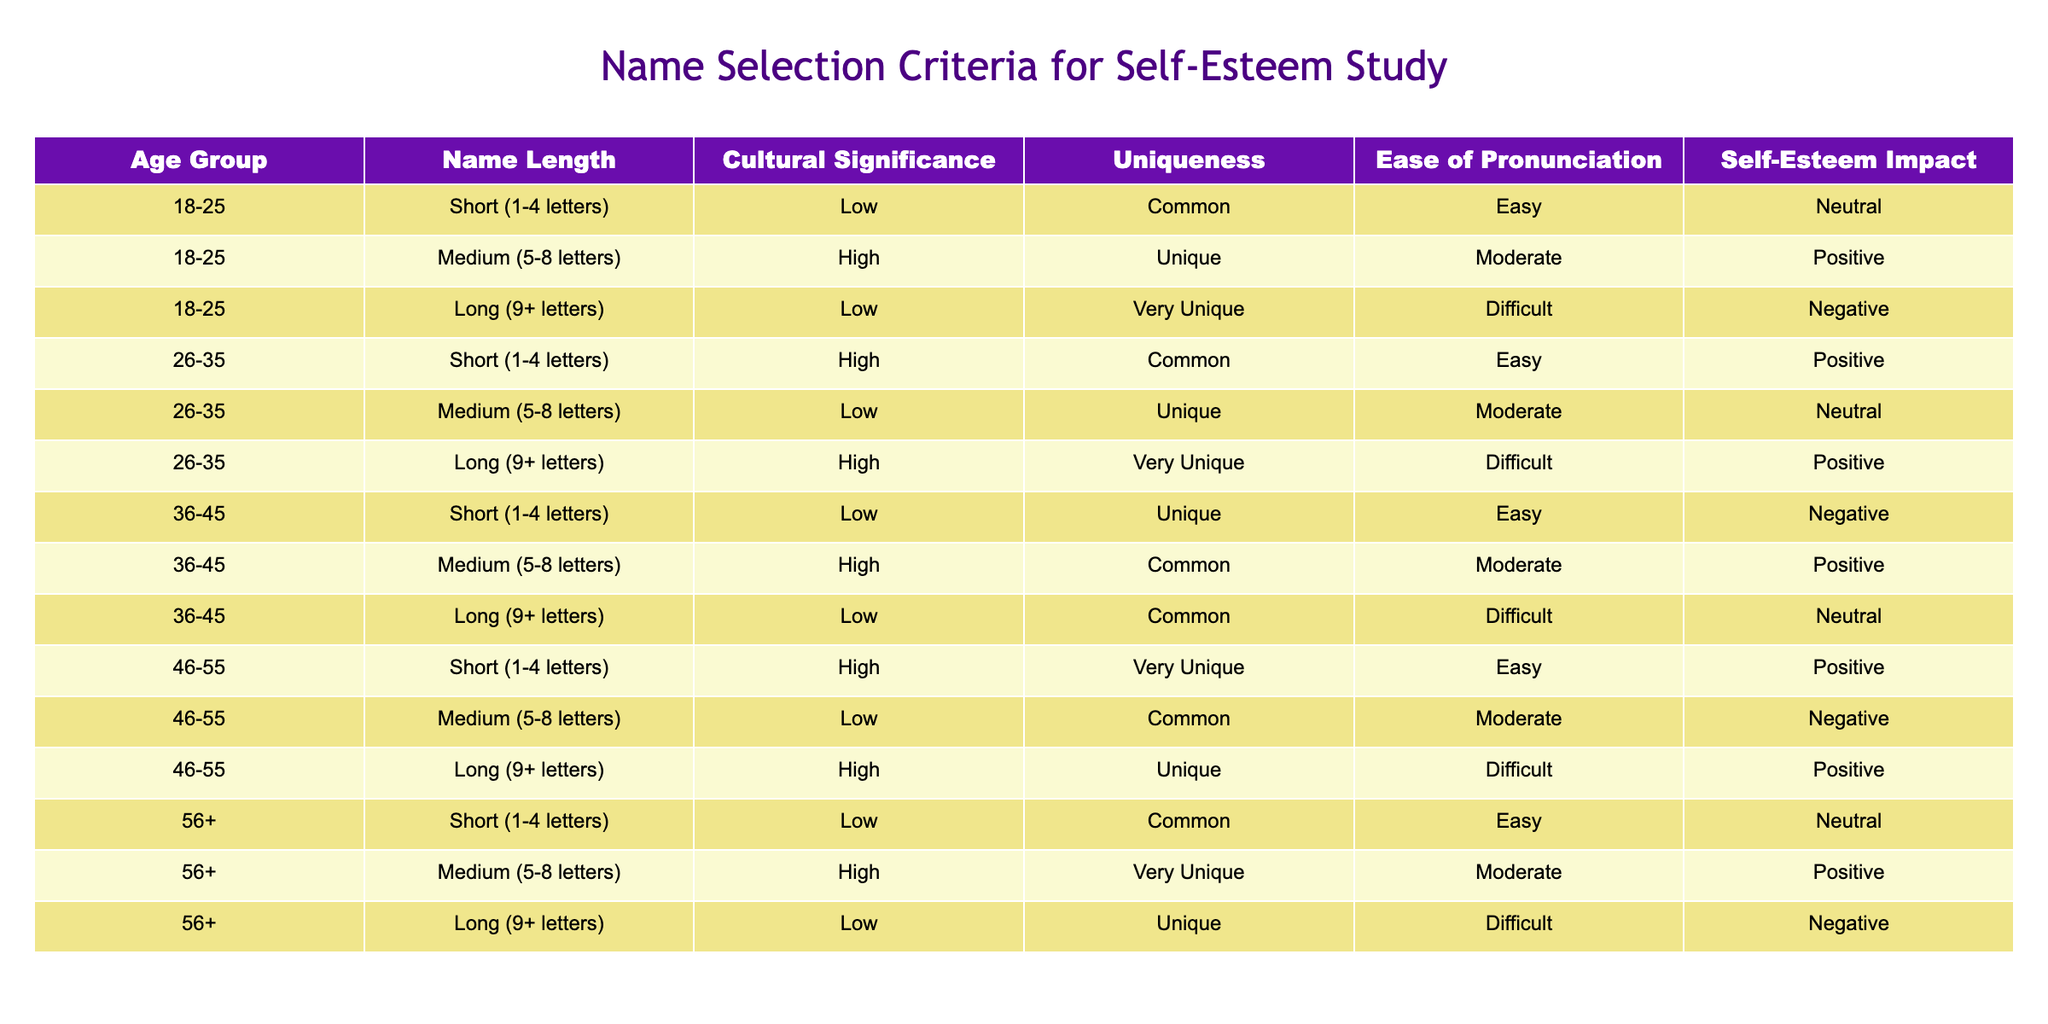What is the self-esteem impact for names of medium length in the 36-45 age group? The self-esteem impact column shows that for the 36-45 age group, the medium length names have a positive impact. I find this in the row corresponding to that age group and name length.
Answer: Positive How many age groups have long names that result in a negative self-esteem impact? Looking at the rows for long names, the age groups with negative self-esteem impacts are 18-25 and 56+. Counting them gives us 2 age groups.
Answer: 2 What is the average name length in characters for the 26-35 age group? In the 26-35 age group, there are three name lengths (short = 4, medium = 8, long = 9). The average is calculated as (4 + 8 + 9) / 3 = 7.
Answer: 7 Is there a unique name for the 18-25 age group that has a positive self-esteem impact? Checking the rows for the 18-25 age group, we see that the medium name length has a high uniqueness and a positive impact, therefore there is a unique name fitting this criterion.
Answer: Yes Which group has the highest self-esteem impact from short names? Evaluating the self-esteem impact for short names in various age groups, the 46-55 age group shows a positive impact, which is the highest among the others that also include negative and neutral impacts.
Answer: 46-55 What is the self-esteem impact difference between medium and long names in the 56+ age group? For the 56+ age group, medium names have a positive self-esteem impact, while long names have a negative impact. The difference is positive (positive - negative = positive).
Answer: Positive 